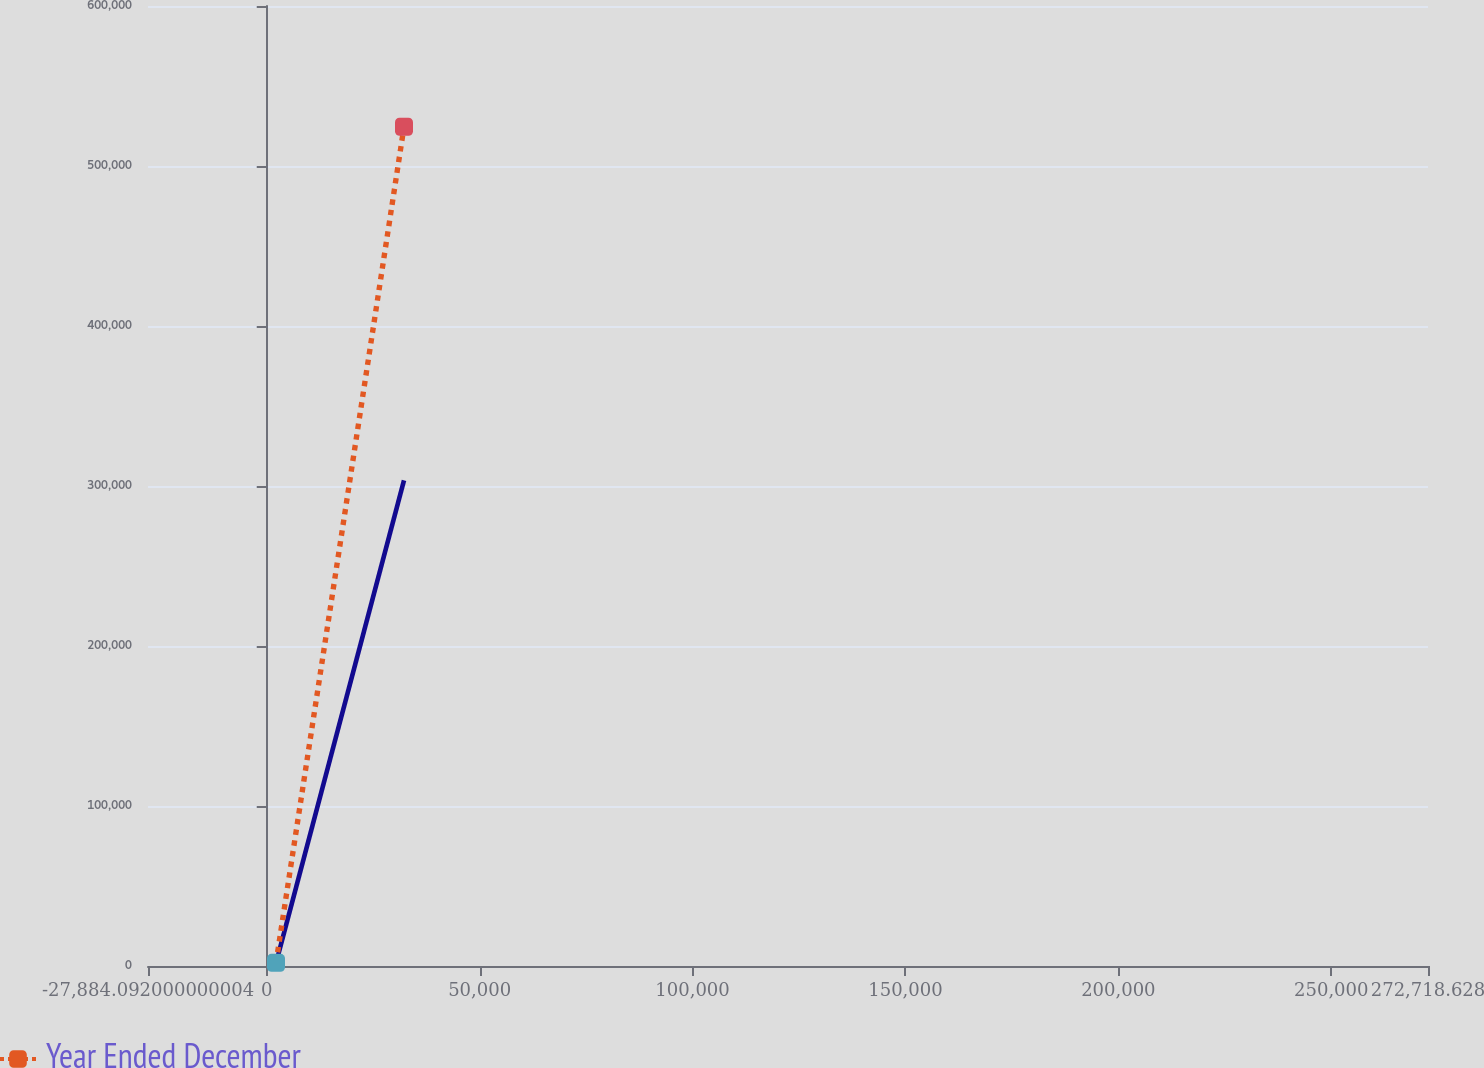Convert chart. <chart><loc_0><loc_0><loc_500><loc_500><line_chart><ecel><fcel>Unnamed: 1<fcel>Year Ended December<nl><fcel>2176.18<fcel>1817.67<fcel>1982.15<nl><fcel>32236.5<fcel>303544<fcel>524514<nl><fcel>302779<fcel>31990.3<fcel>54235.3<nl></chart> 